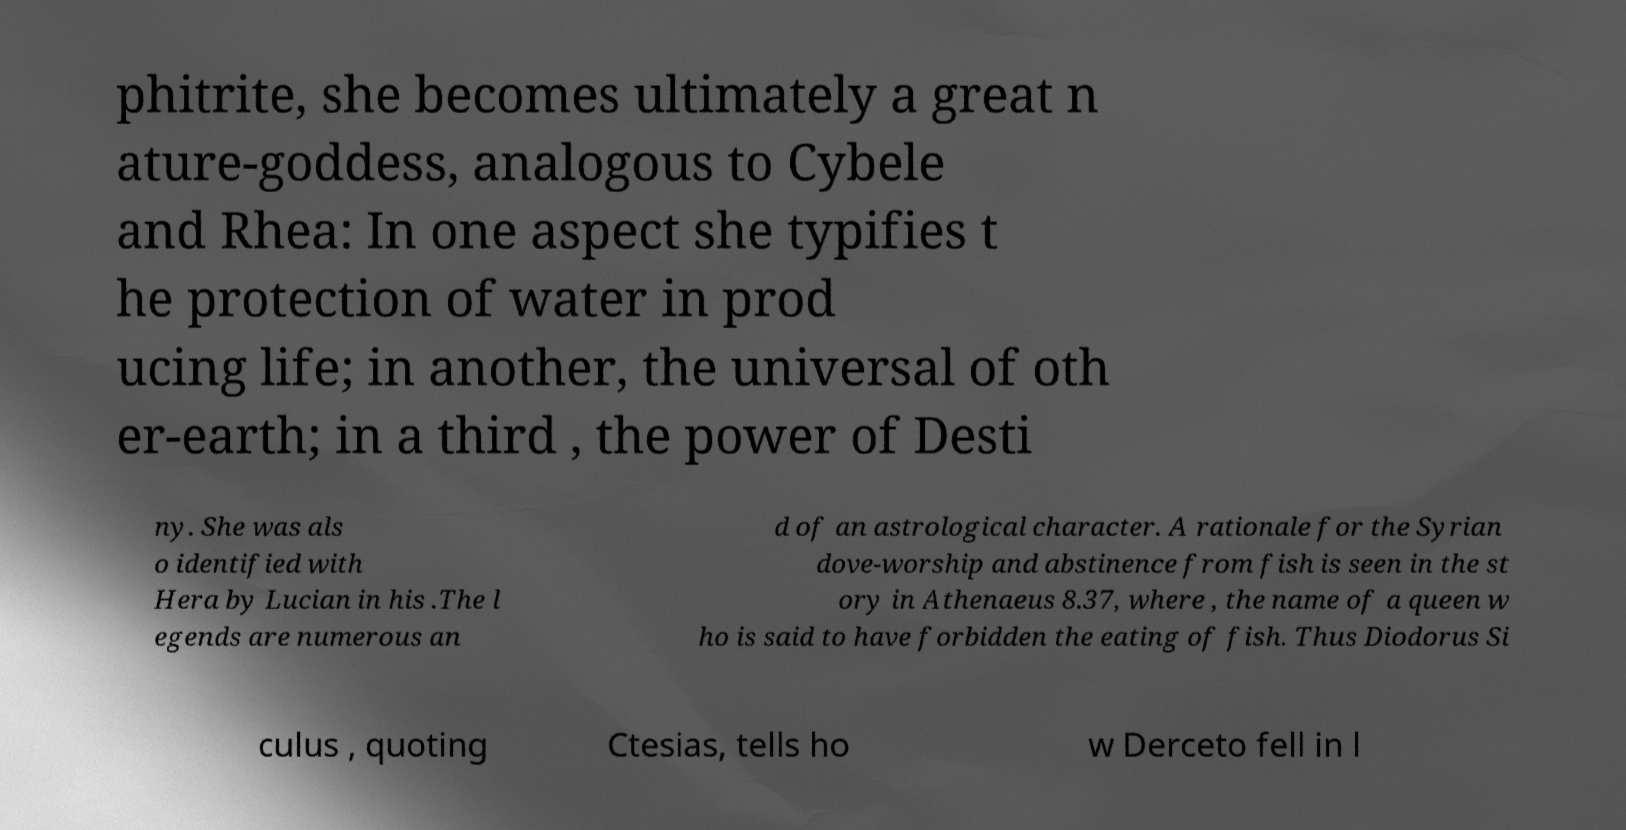Can you read and provide the text displayed in the image?This photo seems to have some interesting text. Can you extract and type it out for me? phitrite, she becomes ultimately a great n ature-goddess, analogous to Cybele and Rhea: In one aspect she typifies t he protection of water in prod ucing life; in another, the universal of oth er-earth; in a third , the power of Desti ny. She was als o identified with Hera by Lucian in his .The l egends are numerous an d of an astrological character. A rationale for the Syrian dove-worship and abstinence from fish is seen in the st ory in Athenaeus 8.37, where , the name of a queen w ho is said to have forbidden the eating of fish. Thus Diodorus Si culus , quoting Ctesias, tells ho w Derceto fell in l 